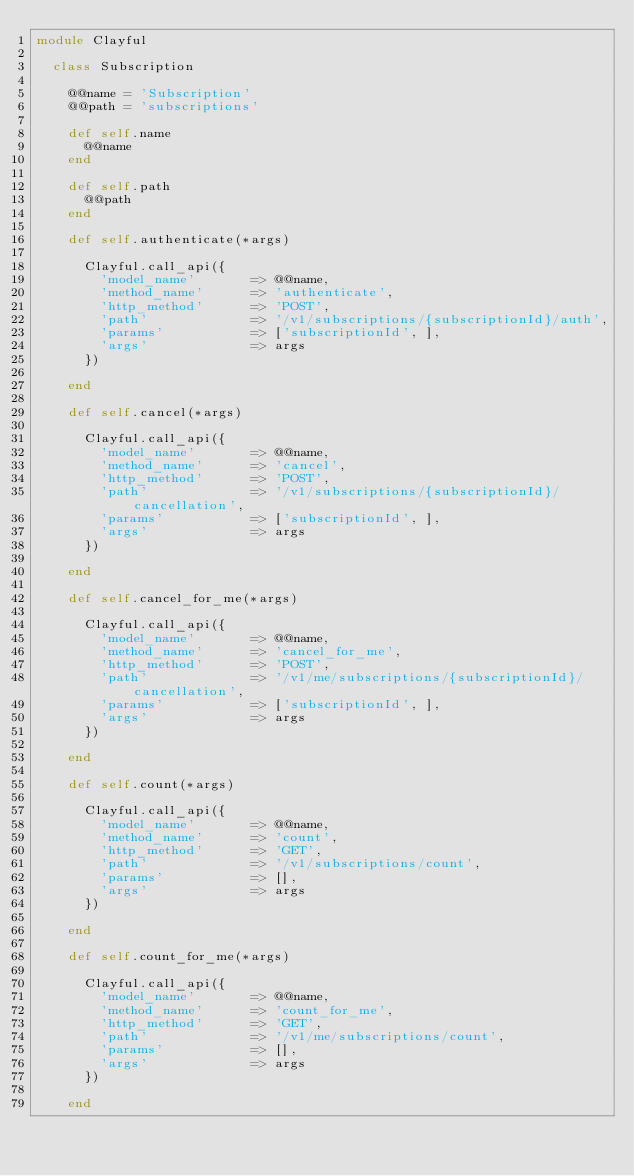Convert code to text. <code><loc_0><loc_0><loc_500><loc_500><_Ruby_>module Clayful

	class Subscription

		@@name = 'Subscription'
		@@path = 'subscriptions'

		def self.name
			@@name
		end

		def self.path
			@@path
		end

		def self.authenticate(*args)

			Clayful.call_api({
				'model_name'       => @@name,
				'method_name'      => 'authenticate',
				'http_method'      => 'POST',
				'path'             => '/v1/subscriptions/{subscriptionId}/auth',
				'params'           => ['subscriptionId', ],
				'args'             => args
			})

		end

		def self.cancel(*args)

			Clayful.call_api({
				'model_name'       => @@name,
				'method_name'      => 'cancel',
				'http_method'      => 'POST',
				'path'             => '/v1/subscriptions/{subscriptionId}/cancellation',
				'params'           => ['subscriptionId', ],
				'args'             => args
			})

		end

		def self.cancel_for_me(*args)

			Clayful.call_api({
				'model_name'       => @@name,
				'method_name'      => 'cancel_for_me',
				'http_method'      => 'POST',
				'path'             => '/v1/me/subscriptions/{subscriptionId}/cancellation',
				'params'           => ['subscriptionId', ],
				'args'             => args
			})

		end

		def self.count(*args)

			Clayful.call_api({
				'model_name'       => @@name,
				'method_name'      => 'count',
				'http_method'      => 'GET',
				'path'             => '/v1/subscriptions/count',
				'params'           => [],
				'args'             => args
			})

		end

		def self.count_for_me(*args)

			Clayful.call_api({
				'model_name'       => @@name,
				'method_name'      => 'count_for_me',
				'http_method'      => 'GET',
				'path'             => '/v1/me/subscriptions/count',
				'params'           => [],
				'args'             => args
			})

		end
</code> 